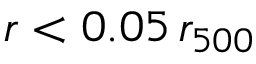Convert formula to latex. <formula><loc_0><loc_0><loc_500><loc_500>r < 0 . 0 5 \, r _ { 5 0 0 }</formula> 